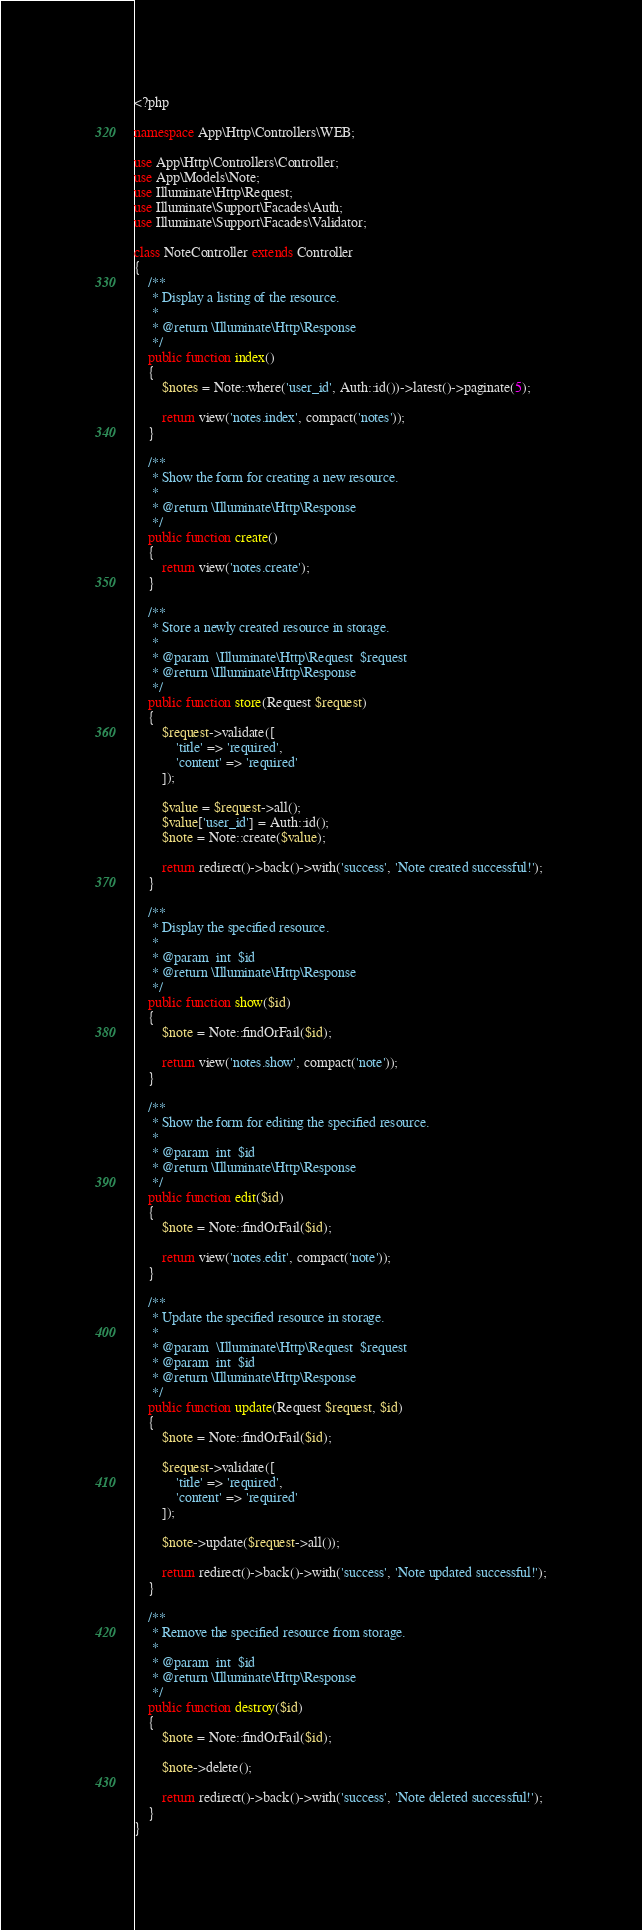<code> <loc_0><loc_0><loc_500><loc_500><_PHP_><?php

namespace App\Http\Controllers\WEB;

use App\Http\Controllers\Controller;
use App\Models\Note;
use Illuminate\Http\Request;
use Illuminate\Support\Facades\Auth;
use Illuminate\Support\Facades\Validator;

class NoteController extends Controller
{
    /**
     * Display a listing of the resource.
     *
     * @return \Illuminate\Http\Response
     */
    public function index()
    {
        $notes = Note::where('user_id', Auth::id())->latest()->paginate(5);

        return view('notes.index', compact('notes'));
    }

    /**
     * Show the form for creating a new resource.
     *
     * @return \Illuminate\Http\Response
     */
    public function create()
    {
        return view('notes.create');
    }

    /**
     * Store a newly created resource in storage.
     *
     * @param  \Illuminate\Http\Request  $request
     * @return \Illuminate\Http\Response
     */
    public function store(Request $request)
    {
        $request->validate([
            'title' => 'required',
            'content' => 'required'
        ]);

        $value = $request->all();
        $value['user_id'] = Auth::id();
        $note = Note::create($value);

        return redirect()->back()->with('success', 'Note created successful!');
    }

    /**
     * Display the specified resource.
     *
     * @param  int  $id
     * @return \Illuminate\Http\Response
     */
    public function show($id)
    {
        $note = Note::findOrFail($id);

        return view('notes.show', compact('note'));
    }

    /**
     * Show the form for editing the specified resource.
     *
     * @param  int  $id
     * @return \Illuminate\Http\Response
     */
    public function edit($id)
    {
        $note = Note::findOrFail($id);

        return view('notes.edit', compact('note'));
    }

    /**
     * Update the specified resource in storage.
     *
     * @param  \Illuminate\Http\Request  $request
     * @param  int  $id
     * @return \Illuminate\Http\Response
     */
    public function update(Request $request, $id)
    {
        $note = Note::findOrFail($id);

        $request->validate([
            'title' => 'required',
            'content' => 'required'
        ]);

        $note->update($request->all());

        return redirect()->back()->with('success', 'Note updated successful!');
    }

    /**
     * Remove the specified resource from storage.
     *
     * @param  int  $id
     * @return \Illuminate\Http\Response
     */
    public function destroy($id)
    {
        $note = Note::findOrFail($id);

        $note->delete();

        return redirect()->back()->with('success', 'Note deleted successful!');
    }
}
</code> 